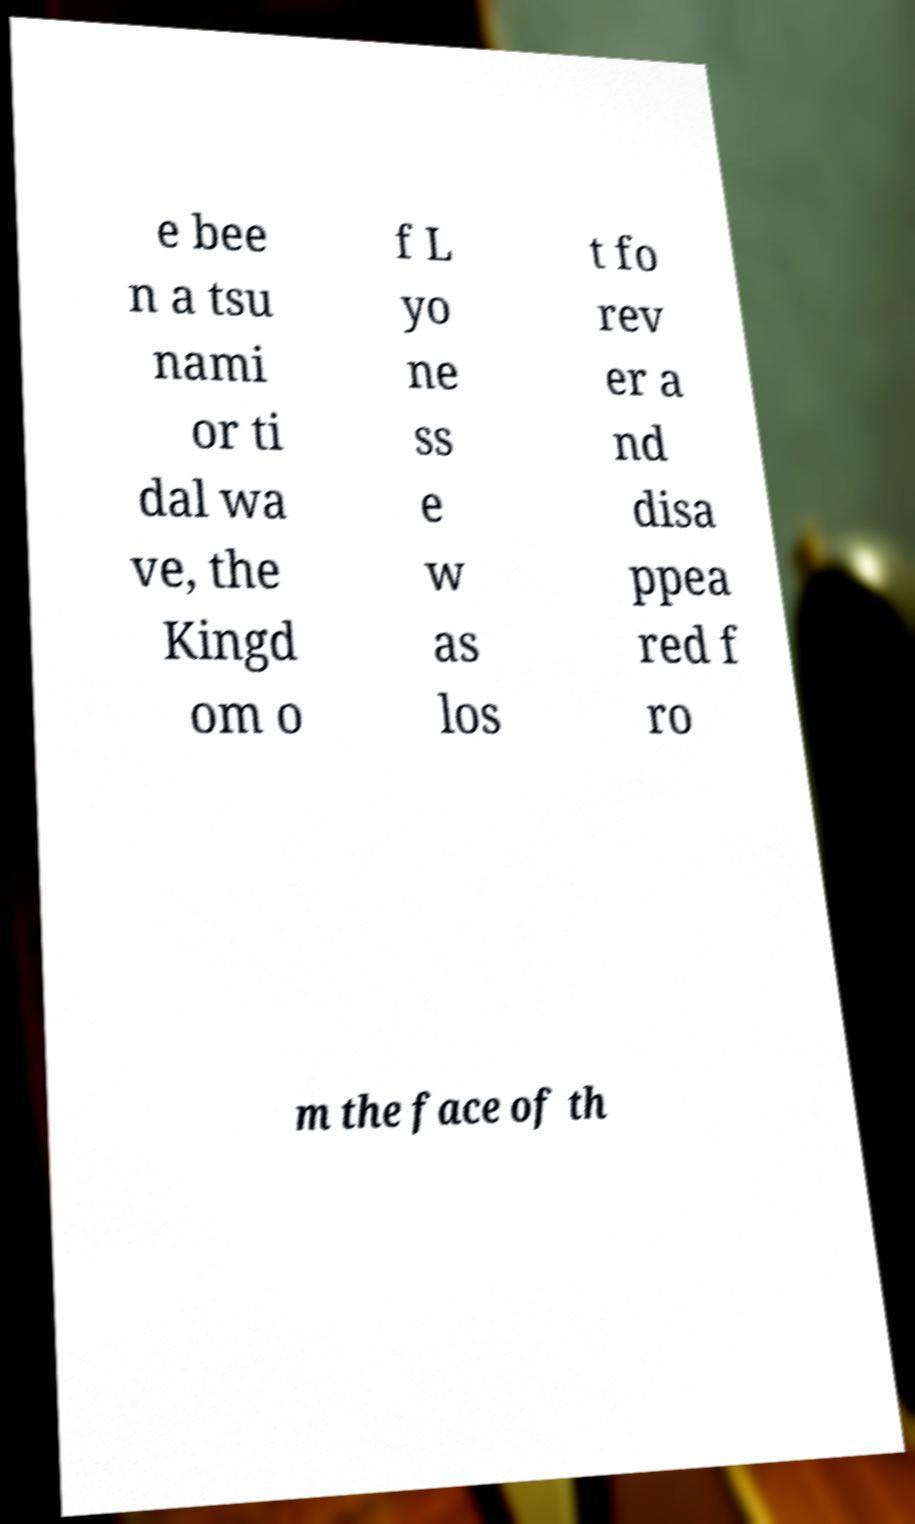Could you extract and type out the text from this image? e bee n a tsu nami or ti dal wa ve, the Kingd om o f L yo ne ss e w as los t fo rev er a nd disa ppea red f ro m the face of th 